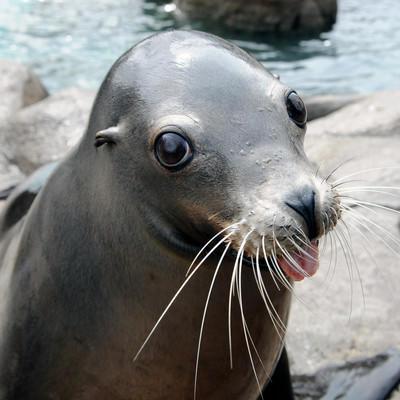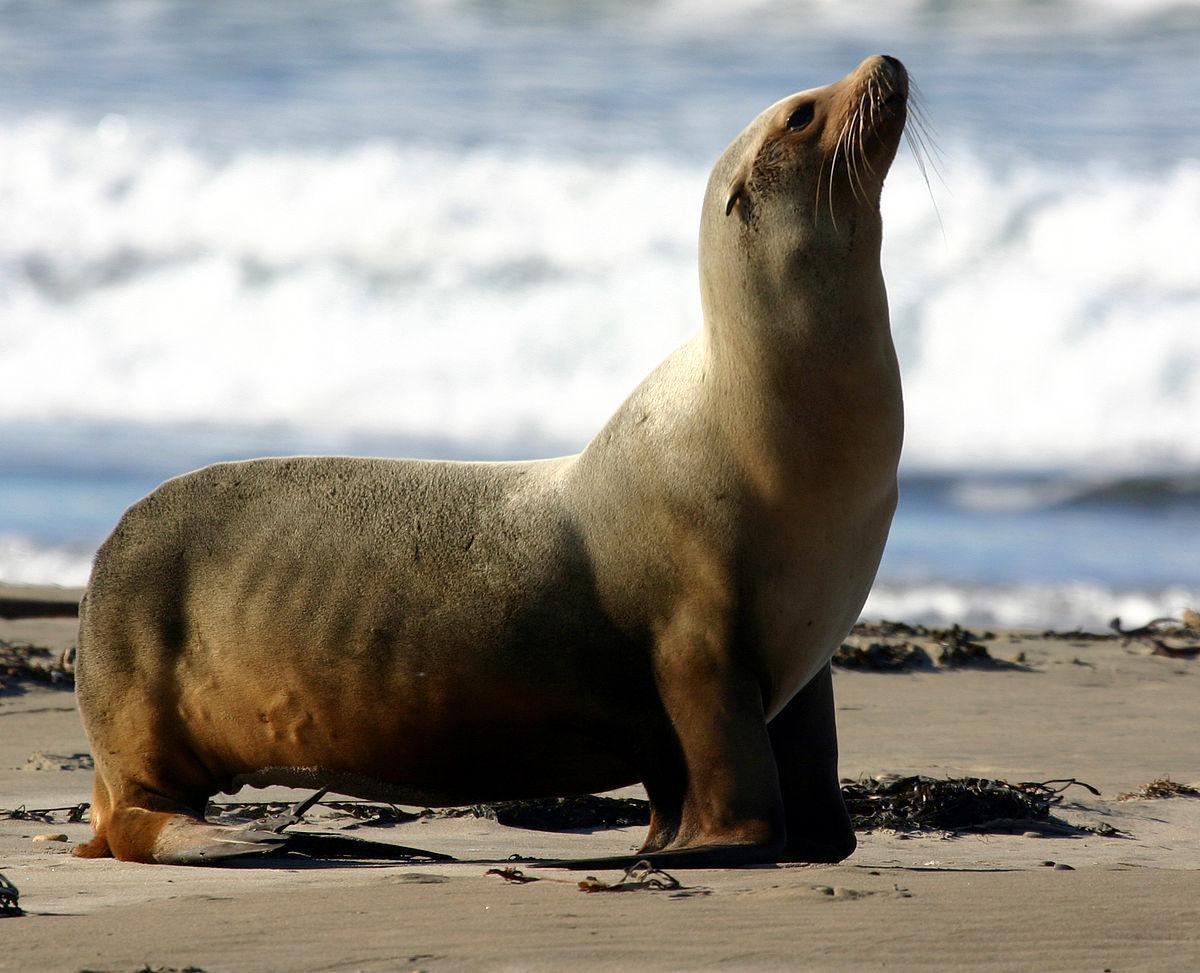The first image is the image on the left, the second image is the image on the right. For the images shown, is this caption "In one of the images there is a single seal next to the edge of a swimming pool." true? Answer yes or no. No. 